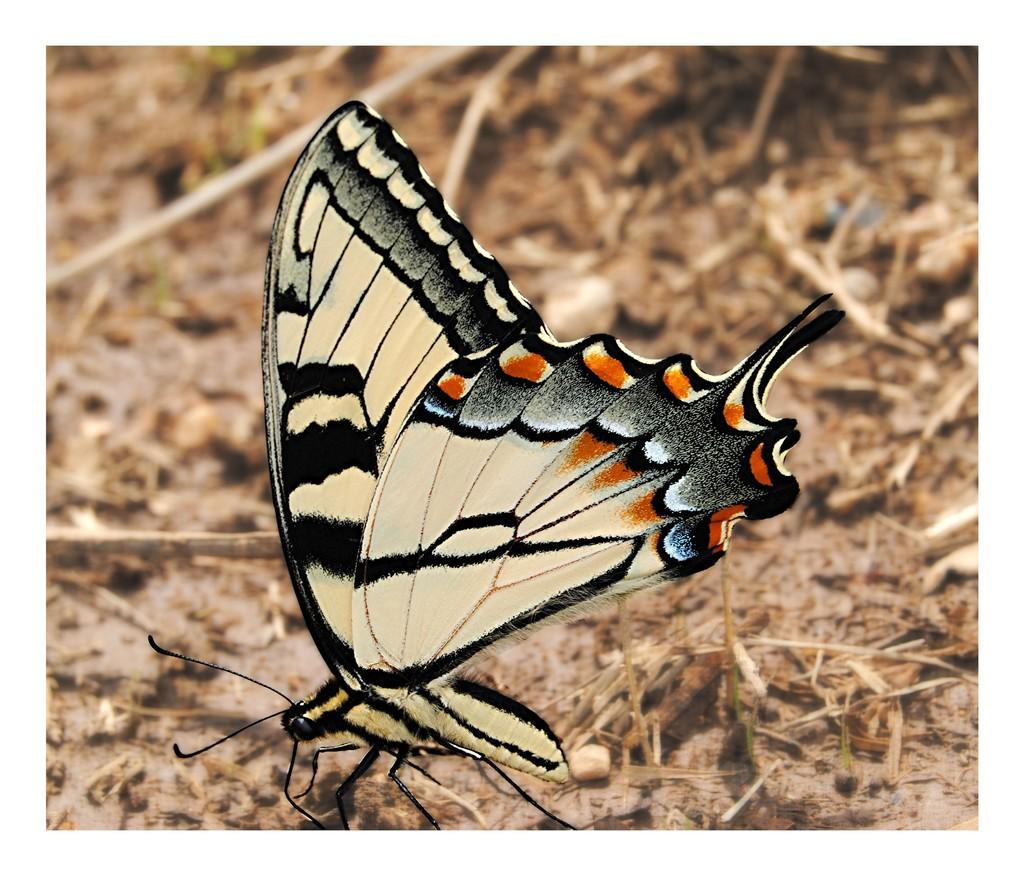What is the main subject of the picture? The main subject of the picture is a butterfly. Can you describe the colors of the butterfly? The butterfly has black, cream, and orange colors. Where is the butterfly located in the image? The butterfly is on the land. What can be seen in the background of the image? There are sticks visible in the background of the image. What type of hat is the butterfly wearing in the image? There is no hat present in the image, as the subject is a butterfly and not a person. 